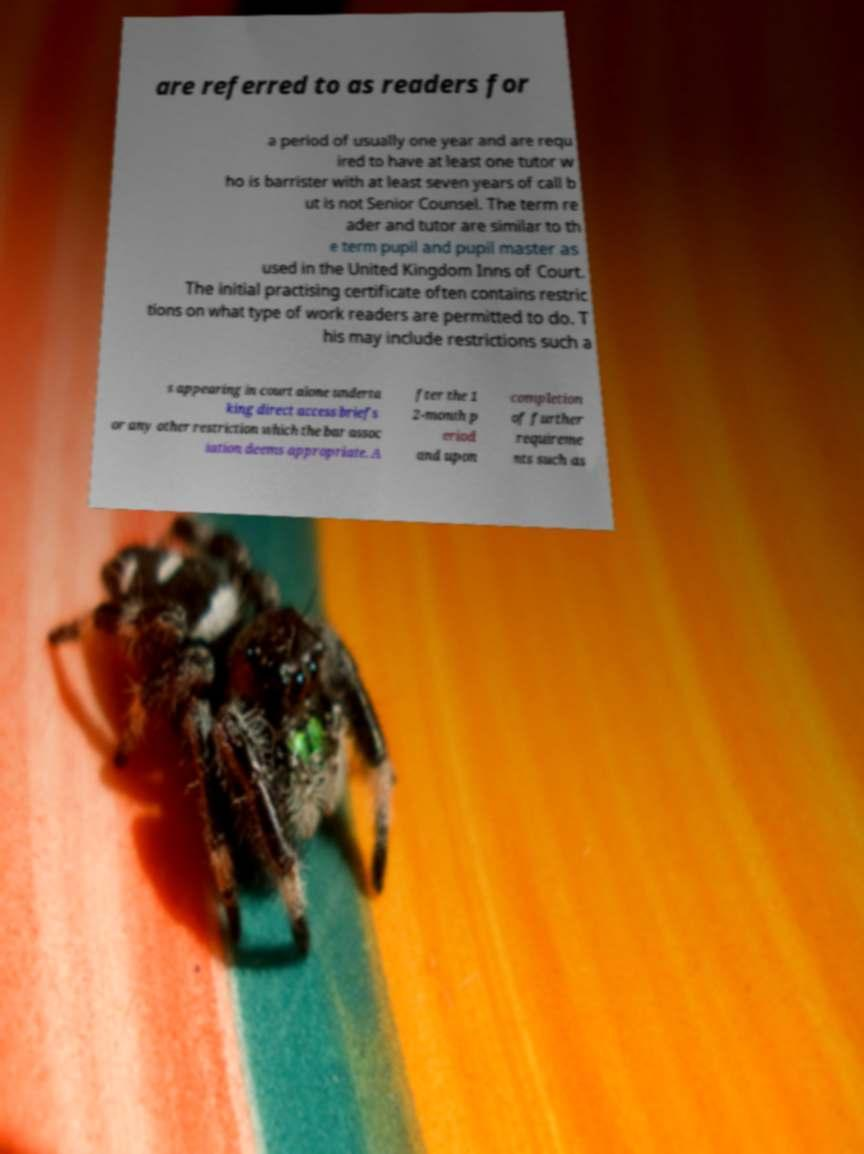Can you accurately transcribe the text from the provided image for me? are referred to as readers for a period of usually one year and are requ ired to have at least one tutor w ho is barrister with at least seven years of call b ut is not Senior Counsel. The term re ader and tutor are similar to th e term pupil and pupil master as used in the United Kingdom Inns of Court. The initial practising certificate often contains restric tions on what type of work readers are permitted to do. T his may include restrictions such a s appearing in court alone underta king direct access briefs or any other restriction which the bar assoc iation deems appropriate. A fter the 1 2-month p eriod and upon completion of further requireme nts such as 